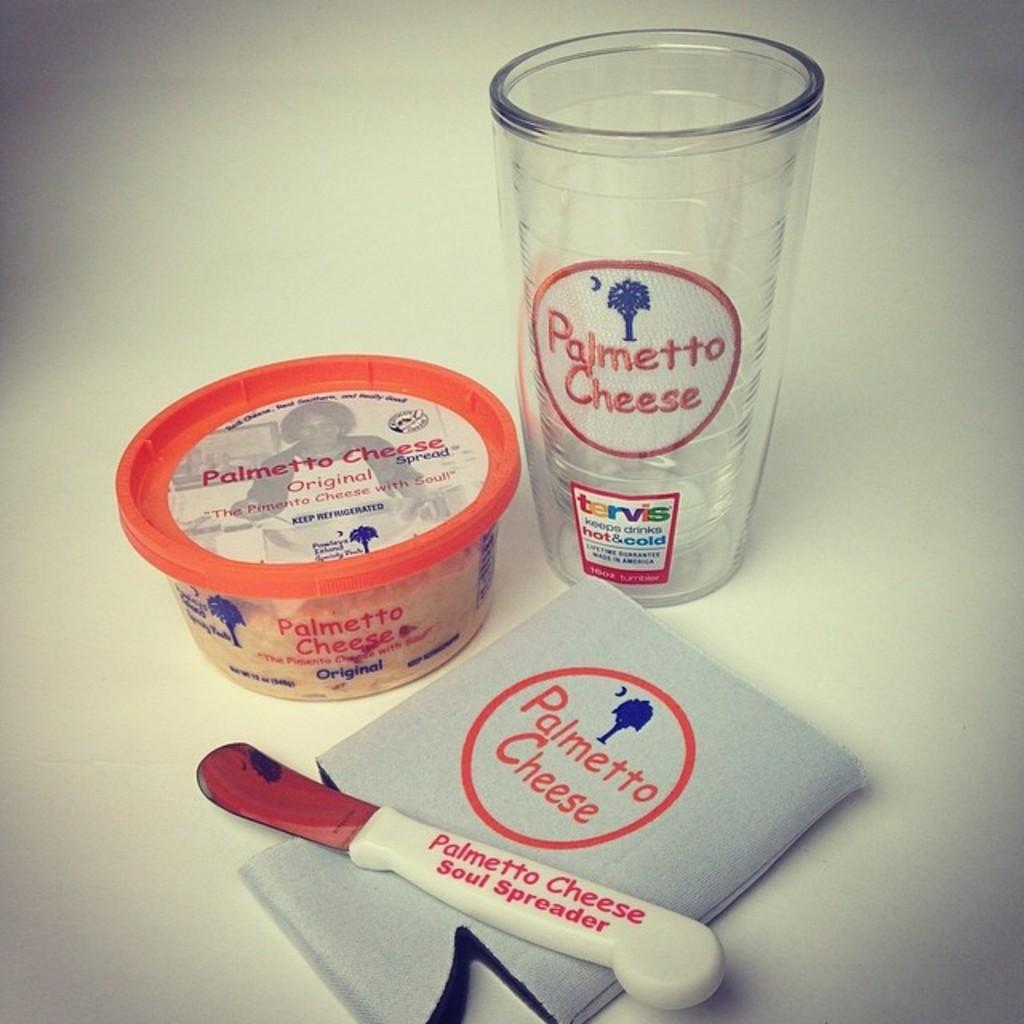What is the main object in the image? There is a box in the image. What other objects can be seen in the image? There is a glass and an object that resembles a knife in the image. What is the color of the background in the image? The background of the image appears to be white in color. Reasoning: Let' Let's think step by step in order to produce the conversation. We start by identifying the main object in the image, which is the box. Then, we expand the conversation to include other objects that are also visible, such as the glass and the knife-like object. Finally, we describe the background of the image, which is white. Each question is designed to elicit a specific detail about the image that is known from the provided facts. Absurd Question/d Question/Answer: How many toes are visible in the image? There are no toes visible in the image. What type of clock is present in the image? There is no clock present in the image. 